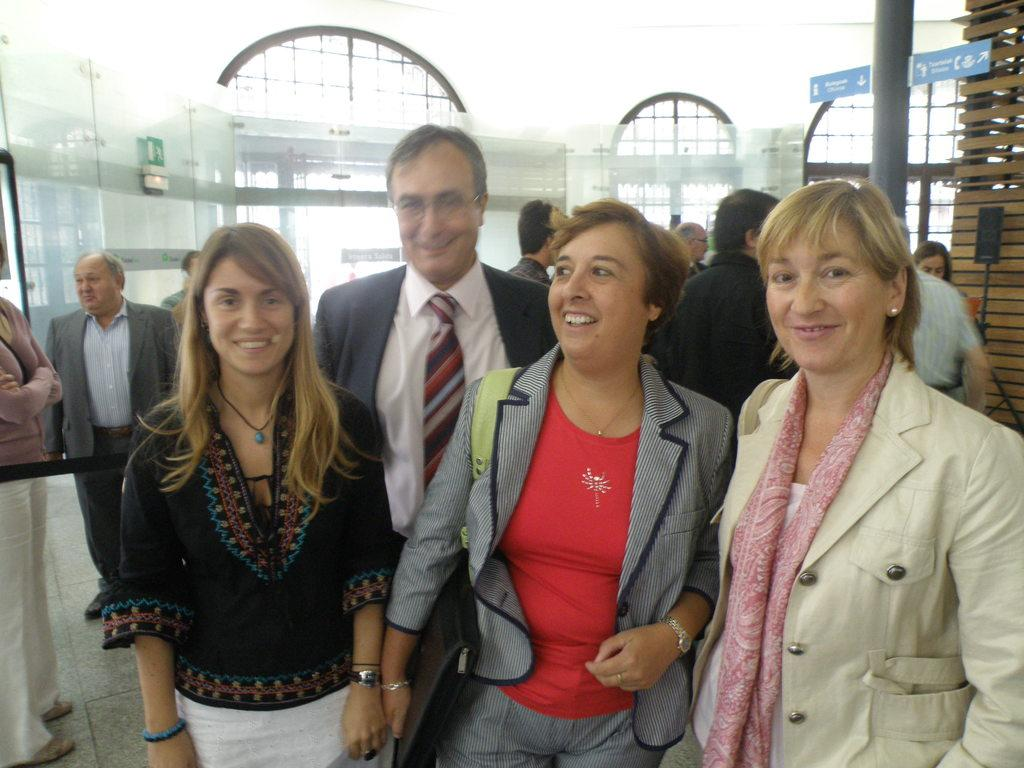What are the people in the image doing? There are persons standing in the image, and some of them are smiling. What can be seen in the background of the image? There are sign boards, windows, and walls in the background of the image. What type of bean is being grown on the island in the image? There is no island or bean present in the image; it features persons standing and elements in the background. What color are the trousers worn by the persons in the image? The provided facts do not mention the color or type of clothing worn by the persons in the image. 